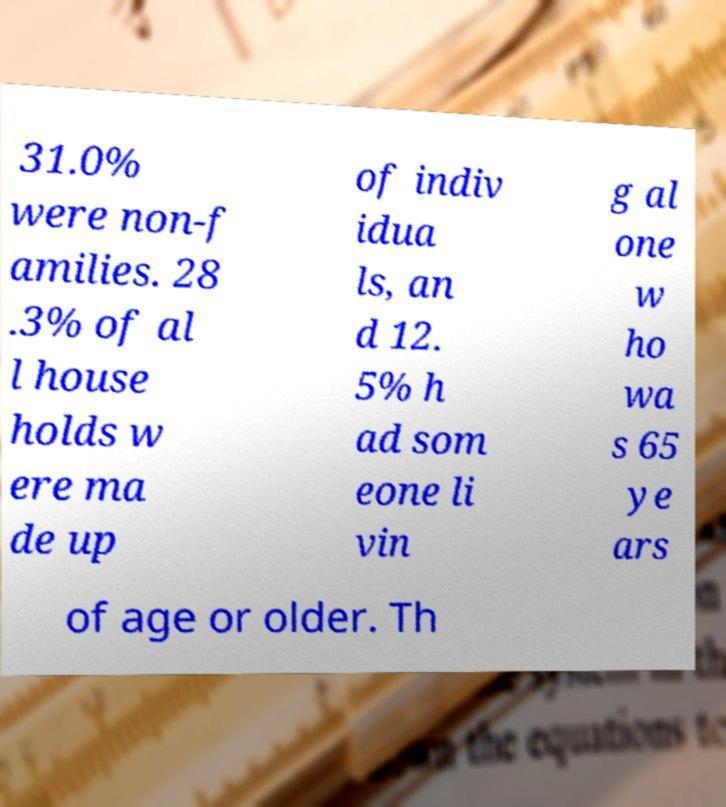Could you extract and type out the text from this image? 31.0% were non-f amilies. 28 .3% of al l house holds w ere ma de up of indiv idua ls, an d 12. 5% h ad som eone li vin g al one w ho wa s 65 ye ars of age or older. Th 